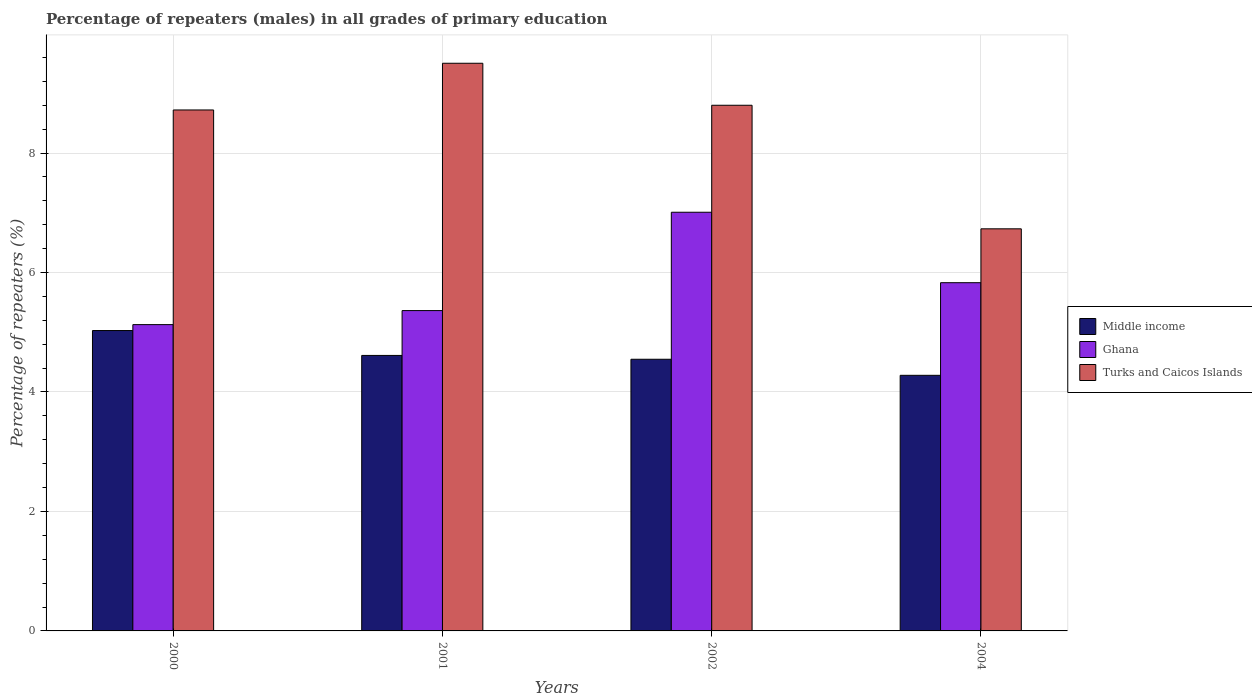How many different coloured bars are there?
Provide a succinct answer. 3. How many bars are there on the 1st tick from the left?
Keep it short and to the point. 3. What is the percentage of repeaters (males) in Ghana in 2004?
Make the answer very short. 5.83. Across all years, what is the maximum percentage of repeaters (males) in Middle income?
Your response must be concise. 5.03. Across all years, what is the minimum percentage of repeaters (males) in Turks and Caicos Islands?
Ensure brevity in your answer.  6.73. In which year was the percentage of repeaters (males) in Middle income maximum?
Your answer should be very brief. 2000. What is the total percentage of repeaters (males) in Ghana in the graph?
Keep it short and to the point. 23.33. What is the difference between the percentage of repeaters (males) in Turks and Caicos Islands in 2000 and that in 2002?
Your answer should be compact. -0.08. What is the difference between the percentage of repeaters (males) in Ghana in 2000 and the percentage of repeaters (males) in Turks and Caicos Islands in 2002?
Give a very brief answer. -3.67. What is the average percentage of repeaters (males) in Ghana per year?
Offer a very short reply. 5.83. In the year 2002, what is the difference between the percentage of repeaters (males) in Middle income and percentage of repeaters (males) in Ghana?
Your answer should be very brief. -2.46. In how many years, is the percentage of repeaters (males) in Turks and Caicos Islands greater than 3.2 %?
Your response must be concise. 4. What is the ratio of the percentage of repeaters (males) in Middle income in 2001 to that in 2004?
Your response must be concise. 1.08. Is the difference between the percentage of repeaters (males) in Middle income in 2000 and 2002 greater than the difference between the percentage of repeaters (males) in Ghana in 2000 and 2002?
Provide a short and direct response. Yes. What is the difference between the highest and the second highest percentage of repeaters (males) in Middle income?
Ensure brevity in your answer.  0.42. What is the difference between the highest and the lowest percentage of repeaters (males) in Middle income?
Ensure brevity in your answer.  0.75. In how many years, is the percentage of repeaters (males) in Turks and Caicos Islands greater than the average percentage of repeaters (males) in Turks and Caicos Islands taken over all years?
Your answer should be very brief. 3. Are all the bars in the graph horizontal?
Offer a very short reply. No. How many legend labels are there?
Give a very brief answer. 3. How are the legend labels stacked?
Make the answer very short. Vertical. What is the title of the graph?
Keep it short and to the point. Percentage of repeaters (males) in all grades of primary education. What is the label or title of the Y-axis?
Ensure brevity in your answer.  Percentage of repeaters (%). What is the Percentage of repeaters (%) of Middle income in 2000?
Make the answer very short. 5.03. What is the Percentage of repeaters (%) in Ghana in 2000?
Offer a terse response. 5.13. What is the Percentage of repeaters (%) in Turks and Caicos Islands in 2000?
Offer a terse response. 8.72. What is the Percentage of repeaters (%) in Middle income in 2001?
Ensure brevity in your answer.  4.61. What is the Percentage of repeaters (%) in Ghana in 2001?
Give a very brief answer. 5.36. What is the Percentage of repeaters (%) of Turks and Caicos Islands in 2001?
Give a very brief answer. 9.5. What is the Percentage of repeaters (%) in Middle income in 2002?
Keep it short and to the point. 4.55. What is the Percentage of repeaters (%) of Ghana in 2002?
Offer a terse response. 7.01. What is the Percentage of repeaters (%) of Turks and Caicos Islands in 2002?
Make the answer very short. 8.8. What is the Percentage of repeaters (%) in Middle income in 2004?
Your answer should be very brief. 4.28. What is the Percentage of repeaters (%) of Ghana in 2004?
Provide a succinct answer. 5.83. What is the Percentage of repeaters (%) in Turks and Caicos Islands in 2004?
Your response must be concise. 6.73. Across all years, what is the maximum Percentage of repeaters (%) in Middle income?
Offer a terse response. 5.03. Across all years, what is the maximum Percentage of repeaters (%) of Ghana?
Offer a terse response. 7.01. Across all years, what is the maximum Percentage of repeaters (%) in Turks and Caicos Islands?
Keep it short and to the point. 9.5. Across all years, what is the minimum Percentage of repeaters (%) in Middle income?
Give a very brief answer. 4.28. Across all years, what is the minimum Percentage of repeaters (%) in Ghana?
Your answer should be very brief. 5.13. Across all years, what is the minimum Percentage of repeaters (%) in Turks and Caicos Islands?
Keep it short and to the point. 6.73. What is the total Percentage of repeaters (%) of Middle income in the graph?
Offer a very short reply. 18.47. What is the total Percentage of repeaters (%) of Ghana in the graph?
Give a very brief answer. 23.33. What is the total Percentage of repeaters (%) in Turks and Caicos Islands in the graph?
Your answer should be very brief. 33.75. What is the difference between the Percentage of repeaters (%) of Middle income in 2000 and that in 2001?
Keep it short and to the point. 0.42. What is the difference between the Percentage of repeaters (%) in Ghana in 2000 and that in 2001?
Keep it short and to the point. -0.23. What is the difference between the Percentage of repeaters (%) in Turks and Caicos Islands in 2000 and that in 2001?
Make the answer very short. -0.78. What is the difference between the Percentage of repeaters (%) in Middle income in 2000 and that in 2002?
Offer a terse response. 0.48. What is the difference between the Percentage of repeaters (%) in Ghana in 2000 and that in 2002?
Ensure brevity in your answer.  -1.88. What is the difference between the Percentage of repeaters (%) in Turks and Caicos Islands in 2000 and that in 2002?
Offer a very short reply. -0.08. What is the difference between the Percentage of repeaters (%) in Middle income in 2000 and that in 2004?
Your response must be concise. 0.75. What is the difference between the Percentage of repeaters (%) of Ghana in 2000 and that in 2004?
Keep it short and to the point. -0.7. What is the difference between the Percentage of repeaters (%) of Turks and Caicos Islands in 2000 and that in 2004?
Your response must be concise. 1.99. What is the difference between the Percentage of repeaters (%) of Middle income in 2001 and that in 2002?
Offer a terse response. 0.06. What is the difference between the Percentage of repeaters (%) of Ghana in 2001 and that in 2002?
Your answer should be compact. -1.65. What is the difference between the Percentage of repeaters (%) of Turks and Caicos Islands in 2001 and that in 2002?
Provide a short and direct response. 0.7. What is the difference between the Percentage of repeaters (%) of Middle income in 2001 and that in 2004?
Make the answer very short. 0.33. What is the difference between the Percentage of repeaters (%) of Ghana in 2001 and that in 2004?
Ensure brevity in your answer.  -0.47. What is the difference between the Percentage of repeaters (%) in Turks and Caicos Islands in 2001 and that in 2004?
Make the answer very short. 2.77. What is the difference between the Percentage of repeaters (%) in Middle income in 2002 and that in 2004?
Your answer should be very brief. 0.27. What is the difference between the Percentage of repeaters (%) in Ghana in 2002 and that in 2004?
Your response must be concise. 1.18. What is the difference between the Percentage of repeaters (%) of Turks and Caicos Islands in 2002 and that in 2004?
Offer a very short reply. 2.07. What is the difference between the Percentage of repeaters (%) in Middle income in 2000 and the Percentage of repeaters (%) in Ghana in 2001?
Your answer should be compact. -0.33. What is the difference between the Percentage of repeaters (%) in Middle income in 2000 and the Percentage of repeaters (%) in Turks and Caicos Islands in 2001?
Provide a short and direct response. -4.47. What is the difference between the Percentage of repeaters (%) in Ghana in 2000 and the Percentage of repeaters (%) in Turks and Caicos Islands in 2001?
Provide a short and direct response. -4.37. What is the difference between the Percentage of repeaters (%) of Middle income in 2000 and the Percentage of repeaters (%) of Ghana in 2002?
Your answer should be compact. -1.98. What is the difference between the Percentage of repeaters (%) of Middle income in 2000 and the Percentage of repeaters (%) of Turks and Caicos Islands in 2002?
Make the answer very short. -3.77. What is the difference between the Percentage of repeaters (%) of Ghana in 2000 and the Percentage of repeaters (%) of Turks and Caicos Islands in 2002?
Provide a short and direct response. -3.67. What is the difference between the Percentage of repeaters (%) of Middle income in 2000 and the Percentage of repeaters (%) of Ghana in 2004?
Give a very brief answer. -0.8. What is the difference between the Percentage of repeaters (%) of Middle income in 2000 and the Percentage of repeaters (%) of Turks and Caicos Islands in 2004?
Provide a short and direct response. -1.7. What is the difference between the Percentage of repeaters (%) in Ghana in 2000 and the Percentage of repeaters (%) in Turks and Caicos Islands in 2004?
Your answer should be compact. -1.6. What is the difference between the Percentage of repeaters (%) of Middle income in 2001 and the Percentage of repeaters (%) of Ghana in 2002?
Your response must be concise. -2.4. What is the difference between the Percentage of repeaters (%) in Middle income in 2001 and the Percentage of repeaters (%) in Turks and Caicos Islands in 2002?
Provide a short and direct response. -4.19. What is the difference between the Percentage of repeaters (%) in Ghana in 2001 and the Percentage of repeaters (%) in Turks and Caicos Islands in 2002?
Ensure brevity in your answer.  -3.44. What is the difference between the Percentage of repeaters (%) in Middle income in 2001 and the Percentage of repeaters (%) in Ghana in 2004?
Your answer should be compact. -1.22. What is the difference between the Percentage of repeaters (%) in Middle income in 2001 and the Percentage of repeaters (%) in Turks and Caicos Islands in 2004?
Your answer should be compact. -2.12. What is the difference between the Percentage of repeaters (%) in Ghana in 2001 and the Percentage of repeaters (%) in Turks and Caicos Islands in 2004?
Your answer should be very brief. -1.37. What is the difference between the Percentage of repeaters (%) of Middle income in 2002 and the Percentage of repeaters (%) of Ghana in 2004?
Give a very brief answer. -1.28. What is the difference between the Percentage of repeaters (%) in Middle income in 2002 and the Percentage of repeaters (%) in Turks and Caicos Islands in 2004?
Provide a succinct answer. -2.18. What is the difference between the Percentage of repeaters (%) in Ghana in 2002 and the Percentage of repeaters (%) in Turks and Caicos Islands in 2004?
Provide a succinct answer. 0.28. What is the average Percentage of repeaters (%) in Middle income per year?
Make the answer very short. 4.62. What is the average Percentage of repeaters (%) in Ghana per year?
Provide a short and direct response. 5.83. What is the average Percentage of repeaters (%) in Turks and Caicos Islands per year?
Your answer should be very brief. 8.44. In the year 2000, what is the difference between the Percentage of repeaters (%) of Middle income and Percentage of repeaters (%) of Ghana?
Your answer should be compact. -0.1. In the year 2000, what is the difference between the Percentage of repeaters (%) of Middle income and Percentage of repeaters (%) of Turks and Caicos Islands?
Give a very brief answer. -3.69. In the year 2000, what is the difference between the Percentage of repeaters (%) in Ghana and Percentage of repeaters (%) in Turks and Caicos Islands?
Ensure brevity in your answer.  -3.59. In the year 2001, what is the difference between the Percentage of repeaters (%) of Middle income and Percentage of repeaters (%) of Ghana?
Keep it short and to the point. -0.75. In the year 2001, what is the difference between the Percentage of repeaters (%) of Middle income and Percentage of repeaters (%) of Turks and Caicos Islands?
Provide a succinct answer. -4.89. In the year 2001, what is the difference between the Percentage of repeaters (%) in Ghana and Percentage of repeaters (%) in Turks and Caicos Islands?
Provide a succinct answer. -4.14. In the year 2002, what is the difference between the Percentage of repeaters (%) of Middle income and Percentage of repeaters (%) of Ghana?
Give a very brief answer. -2.46. In the year 2002, what is the difference between the Percentage of repeaters (%) in Middle income and Percentage of repeaters (%) in Turks and Caicos Islands?
Your response must be concise. -4.25. In the year 2002, what is the difference between the Percentage of repeaters (%) of Ghana and Percentage of repeaters (%) of Turks and Caicos Islands?
Give a very brief answer. -1.79. In the year 2004, what is the difference between the Percentage of repeaters (%) of Middle income and Percentage of repeaters (%) of Ghana?
Your answer should be compact. -1.55. In the year 2004, what is the difference between the Percentage of repeaters (%) of Middle income and Percentage of repeaters (%) of Turks and Caicos Islands?
Provide a succinct answer. -2.45. In the year 2004, what is the difference between the Percentage of repeaters (%) in Ghana and Percentage of repeaters (%) in Turks and Caicos Islands?
Provide a succinct answer. -0.9. What is the ratio of the Percentage of repeaters (%) in Middle income in 2000 to that in 2001?
Your response must be concise. 1.09. What is the ratio of the Percentage of repeaters (%) of Ghana in 2000 to that in 2001?
Provide a succinct answer. 0.96. What is the ratio of the Percentage of repeaters (%) of Turks and Caicos Islands in 2000 to that in 2001?
Your answer should be compact. 0.92. What is the ratio of the Percentage of repeaters (%) of Middle income in 2000 to that in 2002?
Give a very brief answer. 1.11. What is the ratio of the Percentage of repeaters (%) in Ghana in 2000 to that in 2002?
Keep it short and to the point. 0.73. What is the ratio of the Percentage of repeaters (%) of Middle income in 2000 to that in 2004?
Provide a succinct answer. 1.18. What is the ratio of the Percentage of repeaters (%) of Ghana in 2000 to that in 2004?
Your answer should be very brief. 0.88. What is the ratio of the Percentage of repeaters (%) in Turks and Caicos Islands in 2000 to that in 2004?
Provide a succinct answer. 1.3. What is the ratio of the Percentage of repeaters (%) in Middle income in 2001 to that in 2002?
Your answer should be compact. 1.01. What is the ratio of the Percentage of repeaters (%) of Ghana in 2001 to that in 2002?
Keep it short and to the point. 0.77. What is the ratio of the Percentage of repeaters (%) in Turks and Caicos Islands in 2001 to that in 2002?
Offer a very short reply. 1.08. What is the ratio of the Percentage of repeaters (%) of Middle income in 2001 to that in 2004?
Provide a short and direct response. 1.08. What is the ratio of the Percentage of repeaters (%) of Ghana in 2001 to that in 2004?
Make the answer very short. 0.92. What is the ratio of the Percentage of repeaters (%) of Turks and Caicos Islands in 2001 to that in 2004?
Your answer should be compact. 1.41. What is the ratio of the Percentage of repeaters (%) in Middle income in 2002 to that in 2004?
Ensure brevity in your answer.  1.06. What is the ratio of the Percentage of repeaters (%) in Ghana in 2002 to that in 2004?
Your answer should be compact. 1.2. What is the ratio of the Percentage of repeaters (%) in Turks and Caicos Islands in 2002 to that in 2004?
Give a very brief answer. 1.31. What is the difference between the highest and the second highest Percentage of repeaters (%) of Middle income?
Keep it short and to the point. 0.42. What is the difference between the highest and the second highest Percentage of repeaters (%) of Ghana?
Ensure brevity in your answer.  1.18. What is the difference between the highest and the second highest Percentage of repeaters (%) in Turks and Caicos Islands?
Provide a succinct answer. 0.7. What is the difference between the highest and the lowest Percentage of repeaters (%) in Middle income?
Make the answer very short. 0.75. What is the difference between the highest and the lowest Percentage of repeaters (%) in Ghana?
Ensure brevity in your answer.  1.88. What is the difference between the highest and the lowest Percentage of repeaters (%) of Turks and Caicos Islands?
Offer a terse response. 2.77. 